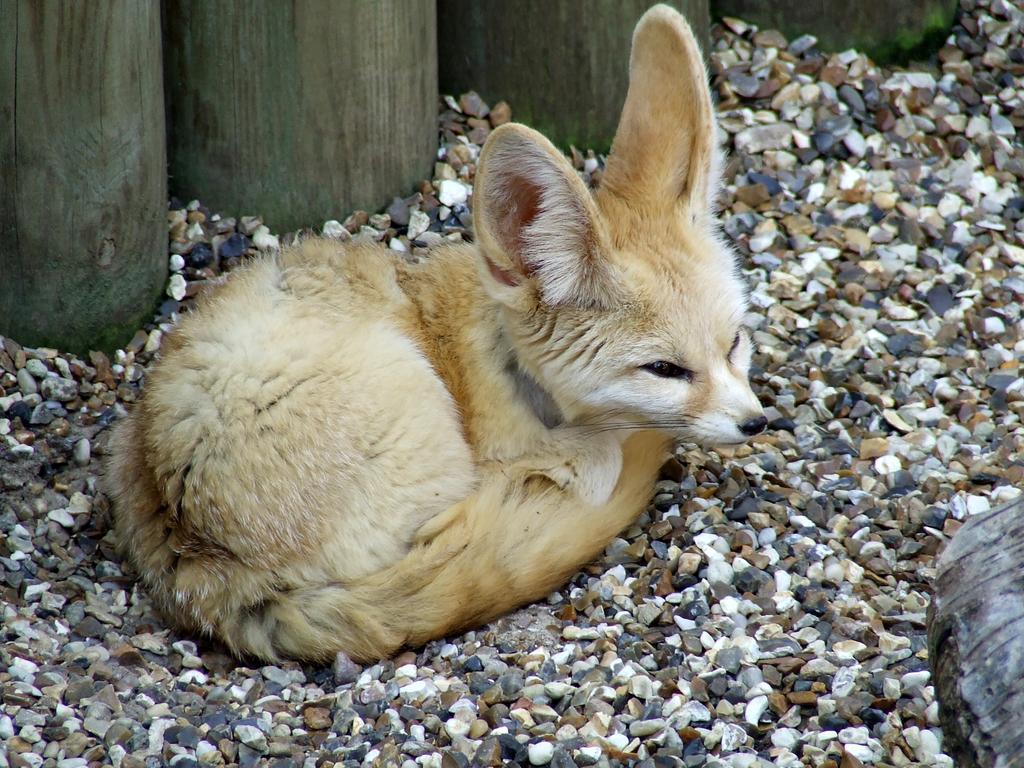How would you summarize this image in a sentence or two? In this image, we can see an animal sitting on the stones. In the background, we can see a wooden trunk. 